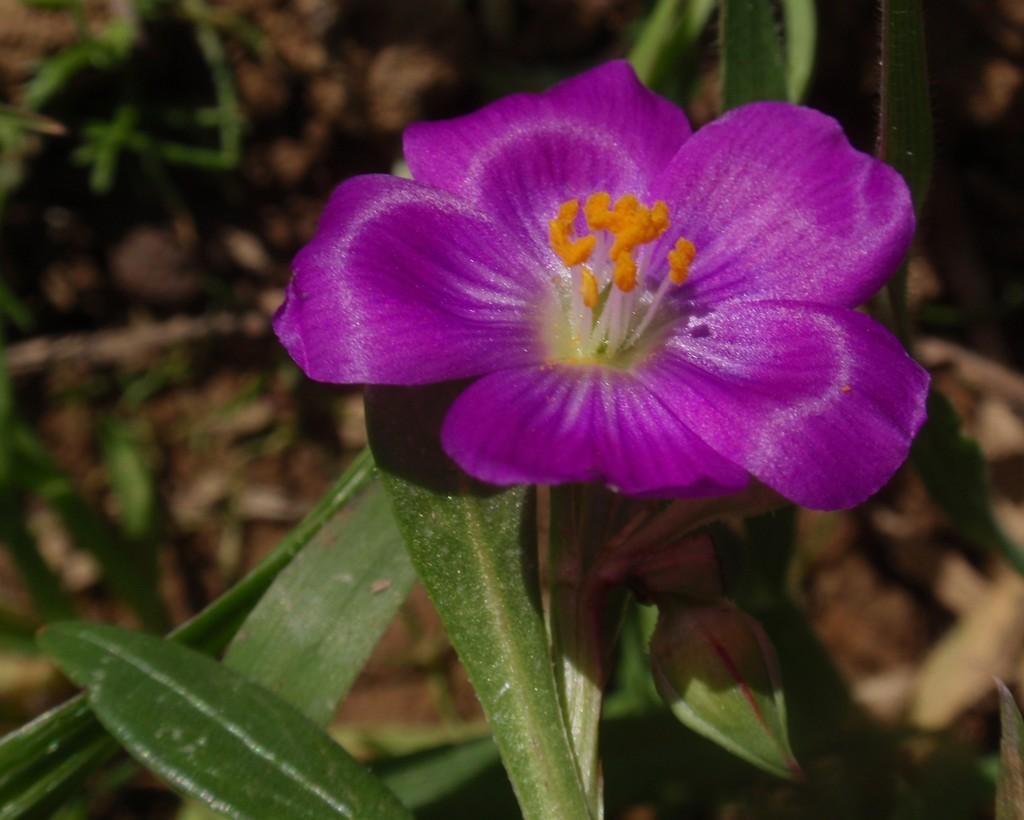How would you summarize this image in a sentence or two? This image is taken outdoors. In the background there is a ground with many dry leaves and a few plants on it. In the middle of the image there is a plant with green leaves and there is a flower which is violet in color. 